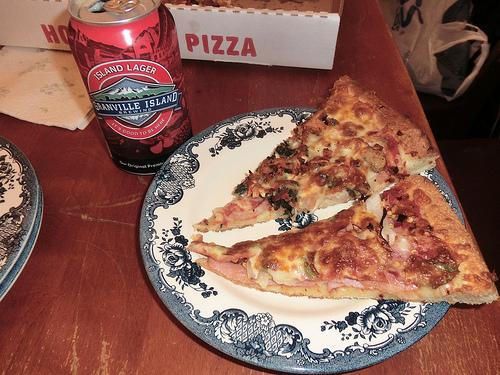Analyze the sentiment conveyed by the image. The image creates a cozy and casual atmosphere, with the delicious-looking pizza, inviting beer, and the unpretentious wooden table setting. Based on the overall composition of the image, what could be the primary purpose of this scene? The primary purpose of the scene might be to display a casual dining setting where pizza and beer are being served, creating an inviting ambience. What other objects can be observed in the image apart from the pizza plate and the beer can? There are napkins under the pizza box, a stack of two unused plates, and a white plastic bag on the floor. Describe the pizza box's design and the text on its surface. The pizza box is white, featuring red letters that read "pizza" on the side of the box. How many slices of pizza are on the plate? What are the colors of the plate? There are two slices of pizza on the plate, and the plate has a blue design on its white surface. List the table's two most visible characteristics. The table is made of scratched distressed wood with a brownish color. Provide a brief description of the contents of the image. The image shows two slices of pizza on a blue and white patterned plate, a red can of lager, a white pizza box with red lettering, and a stack of unused plates on a scratched wooden table. Identify and describe the beverage in the image. A red can of Island Lager beer with a mountain on the label, resting on the table's wooden surface. What type of dish is primarily depicted in the image? Include some toppings observed on this dish. The primary dish in the image consists of two slices of pizza with toppings, including ham, green peppers, and onions. Can you observe any additional items like utensils, cups, or cutlery in the image? No, there are no additional items like utensils, cups, or cutlery visible in the image. Is the green pepper on the pizza actually a small toy car? No, it's not mentioned in the image. What is the main event happening in this image? A meal with pizza and beer Describe the surface of the table. Scratched and distressed wood Read the label on the red can and identify the type of beer. Island lager What type of meal is presented in the image? Casual dining Describe the scene in the image in a simple and concise manner. Two slices of pizza are on a blue-edged white plate, next to a red can of island lager beer on a scratched wooden table with a pizza box, napkins, and stacked plates nearby. Indicate if the scenario is accurate: The pizza box is placed under the napkins. False Explain the layout of the various objects in the image. Two slices of pizza are on a blue-edged white plate on a wooden table, next to a red can of island lager beer. On the table, there's also a pizza box, napkins, stacked plates, and a white plastic bag on the floor. Create a poem about the scene in the image. Upon a table, worn and scarred, What is the color of the can in the image? Red Which objects are placed on the wooden table? Choose from the following options: A) Pizza slices and beer can, B) Plates and napkins, C) Pizza box and plates, D) Pizza slices, beer can, and pizza box A) Pizza slices and beer can Describe the pattern present on the napkin. Green floral pattern What kind of expression is visible on the can's label? Not applicable (N/A) Which objects are resting on the wooden table? Pizza slices, beer can, pizza box, plates, and napkins Is there a snake hiding under the napkins beside the pizza box? This is misleading because there's no mention of any snake or unusual items under or near the napkins. Determine the placement of the can in relation to the pizza slices. The can is to the left of the pizza slices What word is written on the side of the pizza box? Pizza Write a detailed description of the image capturing all elements and their state. The image features a scratched wooden table with two slices of pizza on a white plate with blue design edges, a red can of island lager beer with a mountain on the label, a cardboard box of pizza with the word "pizza" written on it, napkins with green floral pattern under the side of the pizza box, a stack of unused plates, and a white plastic bag on the floor. Identify the toppings visible on the pizza slices. Ham, green pepper, and onion What is the design on the edges of the white plate? Blue pattern 